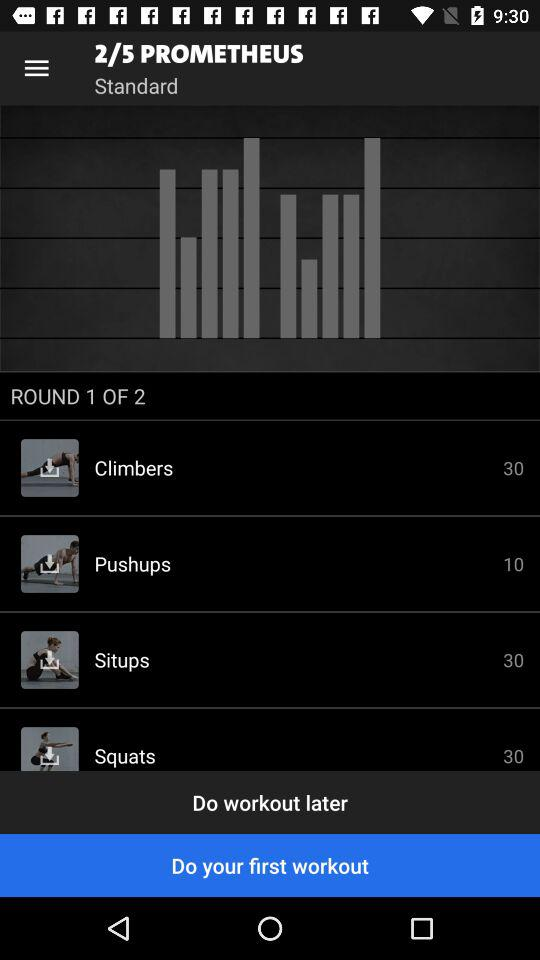How many squats in total are there? There are 30 squats in total. 